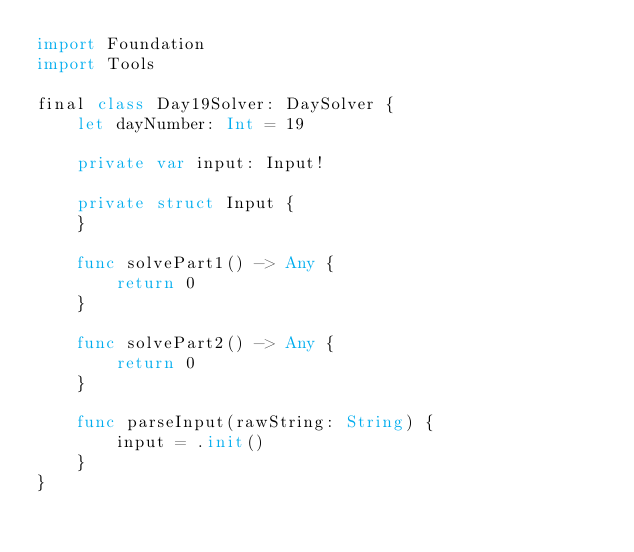Convert code to text. <code><loc_0><loc_0><loc_500><loc_500><_Swift_>import Foundation
import Tools

final class Day19Solver: DaySolver {
    let dayNumber: Int = 19

    private var input: Input!

    private struct Input {
    }

    func solvePart1() -> Any {
        return 0
    }

    func solvePart2() -> Any {
        return 0
    }

    func parseInput(rawString: String) {
        input = .init()
    }
}
</code> 